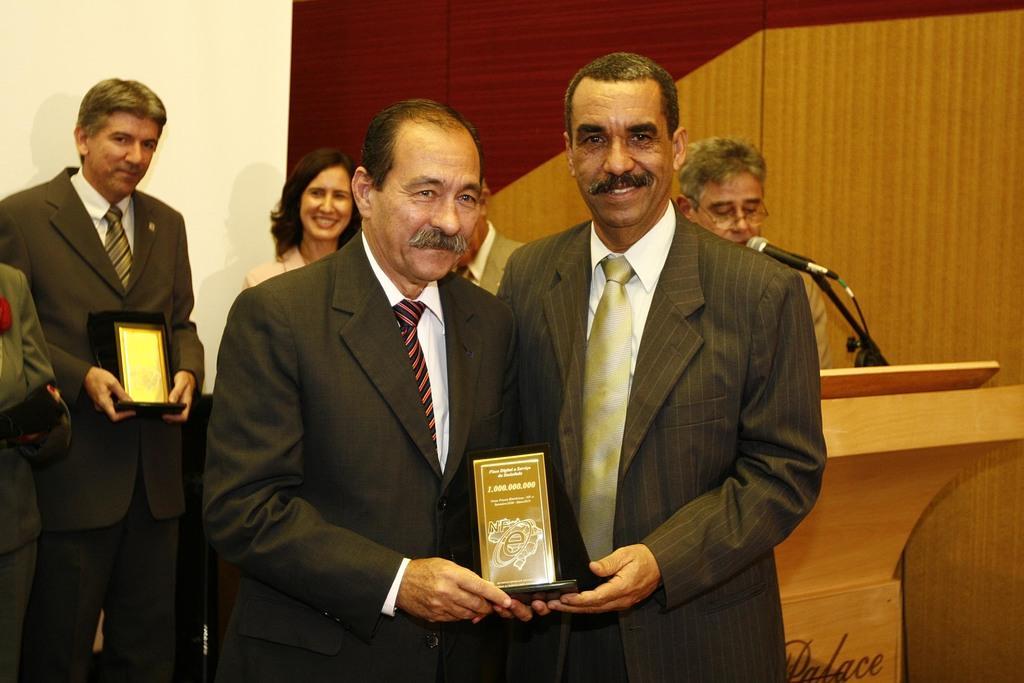Describe this image in one or two sentences. In the picture we can see two men are standing on the floor and holding an award and they are wearing blazers, ties and shirts and they are smiling and behind them, we can see a man talking in the microphone near the desk and besides to him we can see a man and a woman standing and the man is holding an award and behind them we can see a wall and some part is with a wooden wall. 